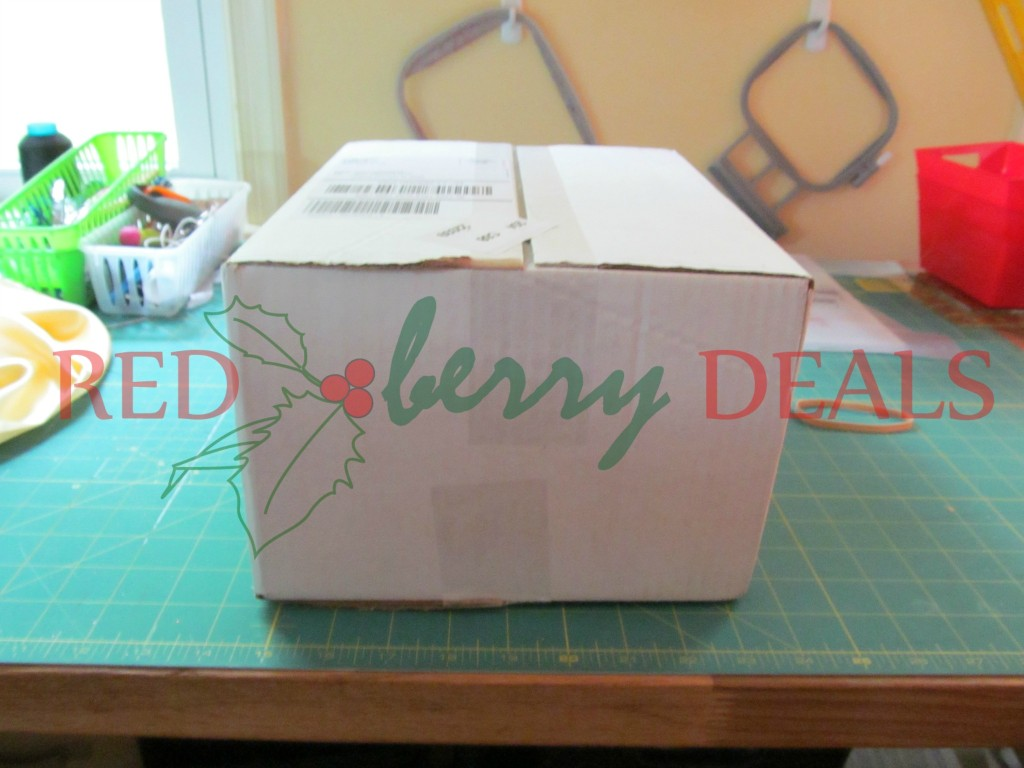Imagine the box as a magical portal to another world. What kind of world would it transport you to? Upon opening the box, you realize it's no ordinary container; it’s a magical portal. Crawling through its opening, you find yourself in an enchanting realm called 'Berrylandia'. The sky is a perpetual twilight, a beautiful gradient of purples and pinks, dotted with countless twinkling stars. The landscape is lush with berry bushes of all kinds: strawberries, blueberries, raspberries, all glowing softly, as if illuminated from within. Tiny, whimsical creatures, reminiscent of fairies and woodland sprites, flutter around, tending to the berry plants. They greet you warmly and offer you delicious berry treats that taste like the essence of pure joy. As you explore further, you discover crystalline rivers running with sweet, berry-flavored water and majestic trees with gilded leaves whispering ancient secrets. Every corner of Berrylandia is suffused with magic, and the air buzzes with the harmony of nature and wonder. What kind of adventures could one have in Berrylandia? In Berrylandia, you could embark on countless enchanting adventures. You might join the berry sprites in their grand Berry Harvest Festival, where you learn to dance like the wind and paint the sky with luminescent colors. Each year, the festival culminates in a dazzling firework display, launched from the tallest enchanted tree. Another adventure could involve helping the wise and ancient Oak Guardian in restoring the Great Berry Amber, a magical gem at the heart of Berrylandia that radiates life and growth. The journey to find the scattered fragments of the Great Berry Amber is filled with captivating challenges like solving ancient puzzles, facing mythical creatures, and unlocking secrets of the old forests and hidden caves. You may also visit the fabulous Berry Falls, where the waterfalls sing mysteries of the deep woods, and you can take a magical swim, discovering underwater palaces built of pearlescent shells and glowing aquatic plants. Each adventure brings you closer to the heart of Berrylandia's enchantment and its boundless wonders. Can you tell me about a more realistic scenario for the box? Certainly. Imagine a scenario where a small local business uses this box to deliver their handmade products to customers. The business, known for its 'RED berry DEALS' branding, carefully packages each order to ensure it arrives safely. Customers look forward to receiving these packages, knowing they contain unique, high-quality items made with care. What about another realistic use case? The box could be used by an online retailer specializing in organic produce. The 'RED berry DEALS' label could indicate a special promotion or a subscription box where customers receive a selection of fresh, organic fruit delivered to their doorstep each month. The shipping label and sturdy packaging ensure that the contents arrive fresh and in good condition. 